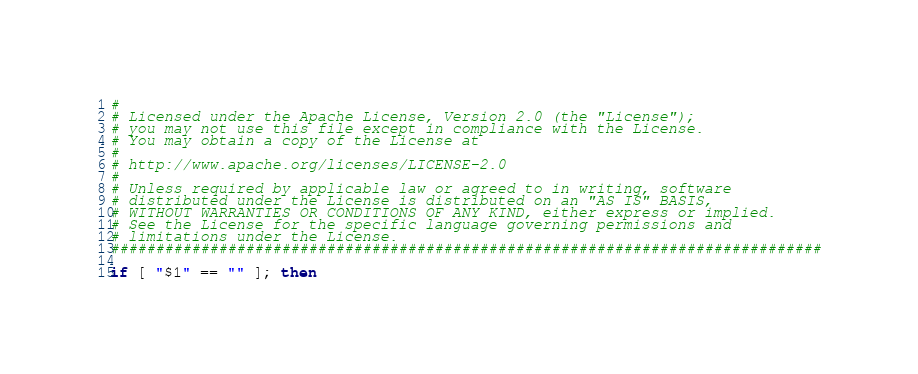Convert code to text. <code><loc_0><loc_0><loc_500><loc_500><_Bash_>#
# Licensed under the Apache License, Version 2.0 (the "License");
# you may not use this file except in compliance with the License.
# You may obtain a copy of the License at
#
# http://www.apache.org/licenses/LICENSE-2.0
#
# Unless required by applicable law or agreed to in writing, software
# distributed under the License is distributed on an "AS IS" BASIS,
# WITHOUT WARRANTIES OR CONDITIONS OF ANY KIND, either express or implied.
# See the License for the specific language governing permissions and
# limitations under the License.
###############################################################################

if [ "$1" == "" ]; then</code> 